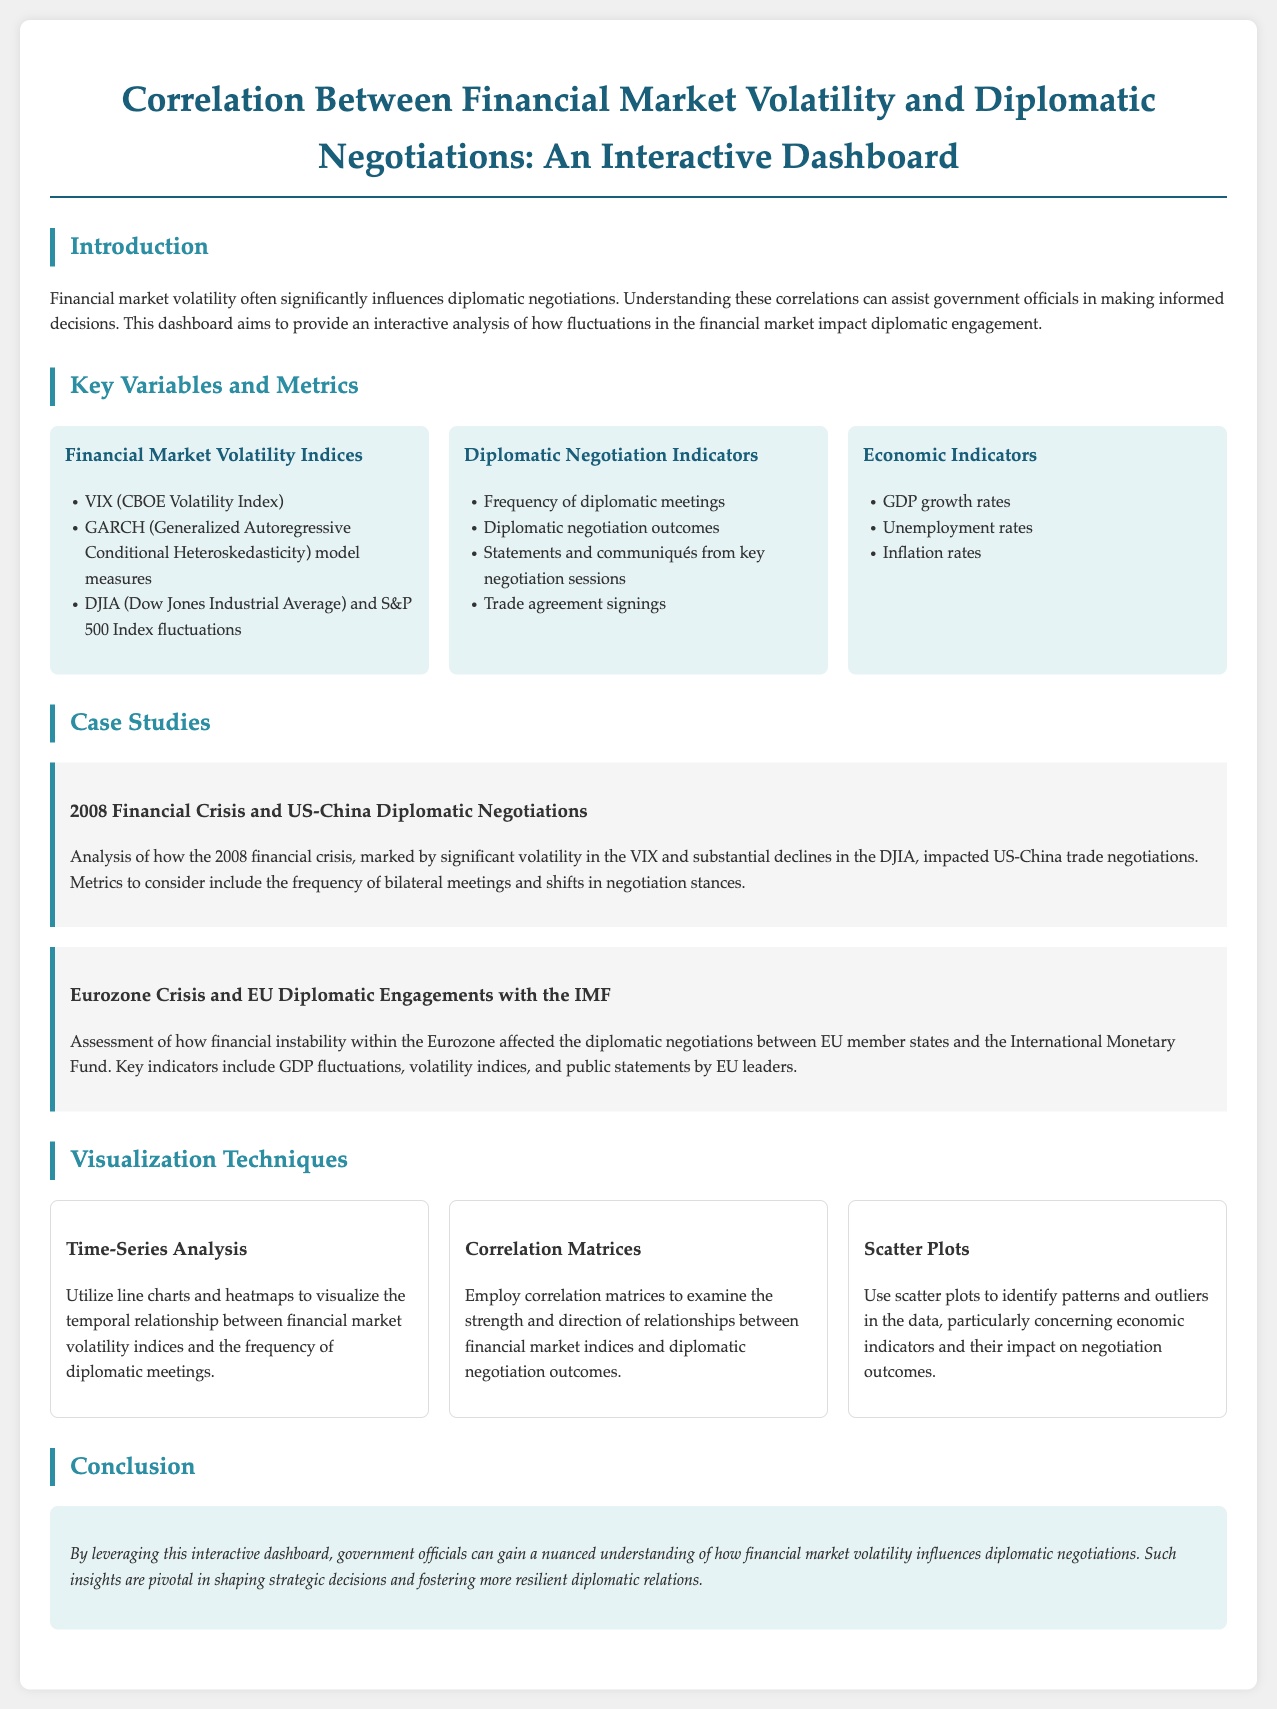What is the main focus of the dashboard? The main focus of the dashboard is the correlation between financial market volatility and diplomatic negotiations.
Answer: Correlation between financial market volatility and diplomatic negotiations What indices are included under Financial Market Volatility? The indices listed for financial market volatility include the VIX, GARCH model measures, and DJIA fluctuations.
Answer: VIX, GARCH, DJIA Which economic indicators are highlighted in the dashboard? The dashboard highlights GDP growth rates, unemployment rates, and inflation rates as economic indicators.
Answer: GDP growth rates, unemployment rates, inflation rates What case study examines the US-China negotiations? The 2008 Financial Crisis and US-China Diplomatic Negotiations case study examines these negotiations.
Answer: 2008 Financial Crisis and US-China Diplomatic Negotiations What visualization technique is used to show temporal relationships? Time-Series Analysis is utilized to visualize the temporal relationship between financial market volatility indices and diplomatic meetings.
Answer: Time-Series Analysis What does the correlation matrix analyze? The correlation matrix analyzes the strength and direction of relationships between financial market indices and negotiation outcomes.
Answer: Strength and direction of relationships between financial market indices and negotiation outcomes What is the significance of the dashboard for government officials? The dashboard provides a nuanced understanding of how financial market volatility influences diplomatic negotiations, aiding strategic decisions.
Answer: A nuanced understanding aiding strategic decisions 